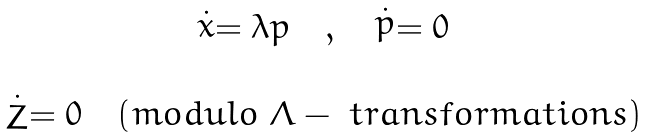Convert formula to latex. <formula><loc_0><loc_0><loc_500><loc_500>\begin{array} { c } \stackrel { . } { x } = \lambda p \quad , \quad \stackrel { . } { p } = 0 \\ \\ \stackrel { . } { Z } = 0 \quad ( m o d u l o \ \Lambda - \ t r a n s f o r m a t i o n s ) \end{array}</formula> 